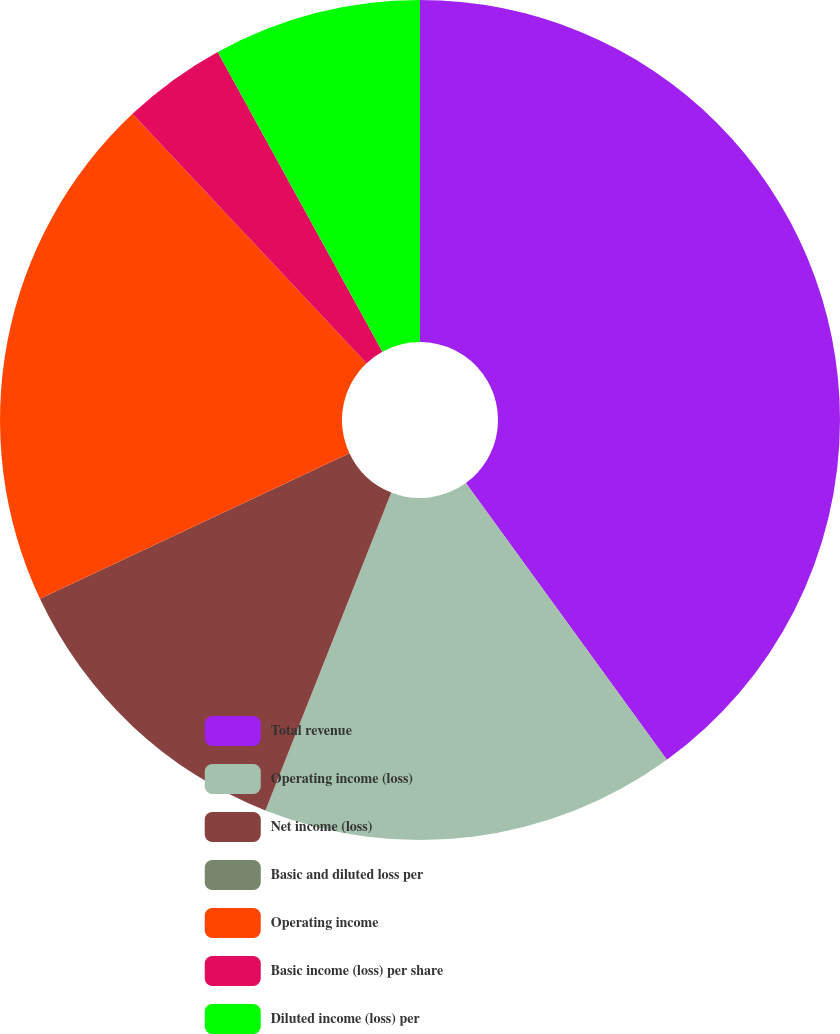<chart> <loc_0><loc_0><loc_500><loc_500><pie_chart><fcel>Total revenue<fcel>Operating income (loss)<fcel>Net income (loss)<fcel>Basic and diluted loss per<fcel>Operating income<fcel>Basic income (loss) per share<fcel>Diluted income (loss) per<nl><fcel>40.0%<fcel>16.0%<fcel>12.0%<fcel>0.0%<fcel>20.0%<fcel>4.0%<fcel>8.0%<nl></chart> 